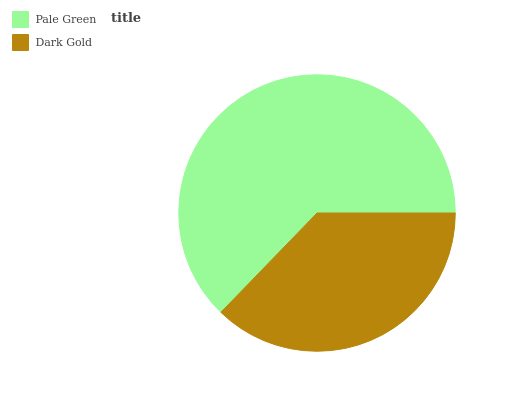Is Dark Gold the minimum?
Answer yes or no. Yes. Is Pale Green the maximum?
Answer yes or no. Yes. Is Dark Gold the maximum?
Answer yes or no. No. Is Pale Green greater than Dark Gold?
Answer yes or no. Yes. Is Dark Gold less than Pale Green?
Answer yes or no. Yes. Is Dark Gold greater than Pale Green?
Answer yes or no. No. Is Pale Green less than Dark Gold?
Answer yes or no. No. Is Pale Green the high median?
Answer yes or no. Yes. Is Dark Gold the low median?
Answer yes or no. Yes. Is Dark Gold the high median?
Answer yes or no. No. Is Pale Green the low median?
Answer yes or no. No. 